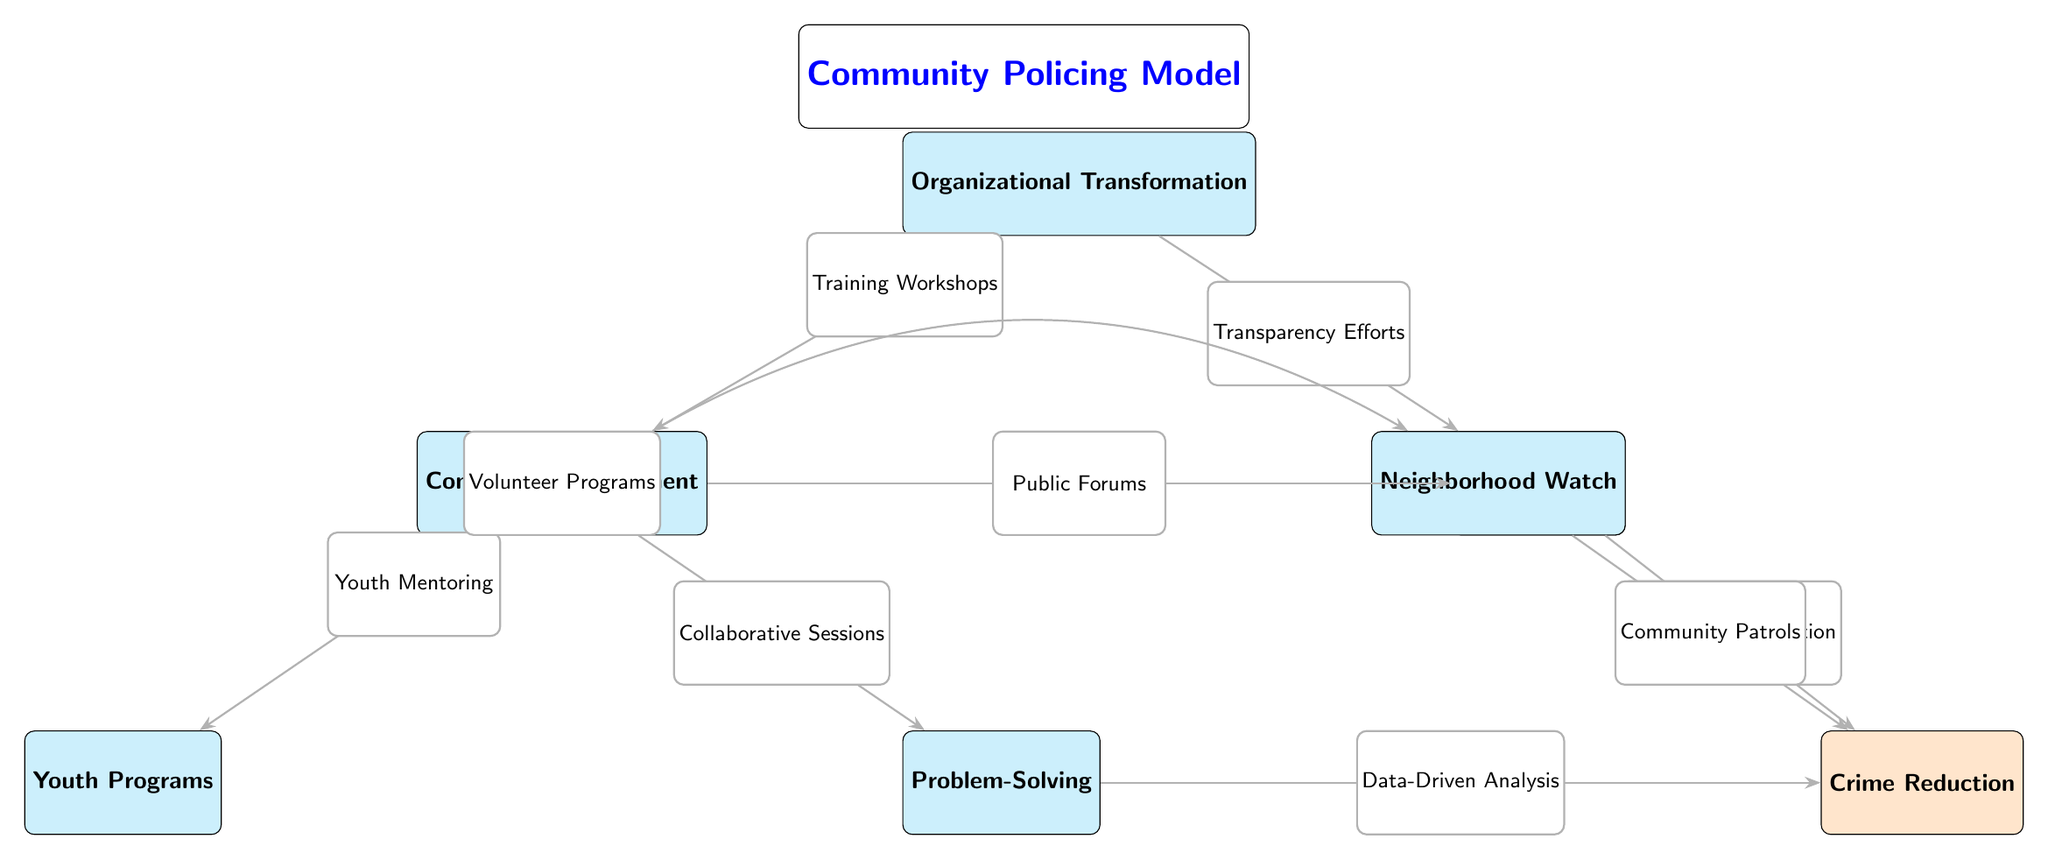What are the three strategies displayed in the model? The model highlights three strategies: Community Engagement, Problem-Solving, and Organizational Transformation. These are identifiable as rounded boxes at the top and sides of the diagram.
Answer: Community Engagement, Problem-Solving, Organizational Transformation How many benefits are outlined in the diagram? The diagram shows three benefits: Trust Building, Crime Reduction, and Enhanced Cooperation. Counting these three rounded boxes indicates the total number of benefits.
Answer: Three What is the first strategy listed in the model? Community Engagement is the first node in the diagram, located at the top. This position signifies its primary importance in the community policing model.
Answer: Community Engagement What connects Youth Programs to Community Engagement? The connection between Youth Programs and Community Engagement is established through an edge labeled 'Youth Mentoring'. This indicates the direct relationship and strategy involved.
Answer: Youth Mentoring What is the relationship between Problem-Solving and Crime Reduction? The relationship is illustrated with an arrow labeled 'Data-Driven Analysis' leading from Problem-Solving to Crime Reduction, indicating an action that directly influences the outcome.
Answer: Data-Driven Analysis What strategy leads to Trust Building? Trust Building is influenced by multiple strategies, but the direct connection from Community Engagement is shown through the 'Public Forums' edge, indicating how it contributes to building trust.
Answer: Community Engagement Which benefit is located directly below Trust Building? The benefit located directly below Trust Building is Crime Reduction, reflected by its position in the diagram where it follows Trust Building vertically.
Answer: Crime Reduction How many nodes represent strategies in the diagram? There are four strategy nodes represented in the diagram: Community Engagement, Problem-Solving, Organizational Transformation, and Youth Programs. Counting these figures gives the total strategies in the model.
Answer: Four Which program directly connects to Community Patrols? The program that leads directly to Community Patrols is Neighborhood Watch, highlighted by an arrow flowing from Neighborhood Watch to Community Patrols.
Answer: Neighborhood Watch 